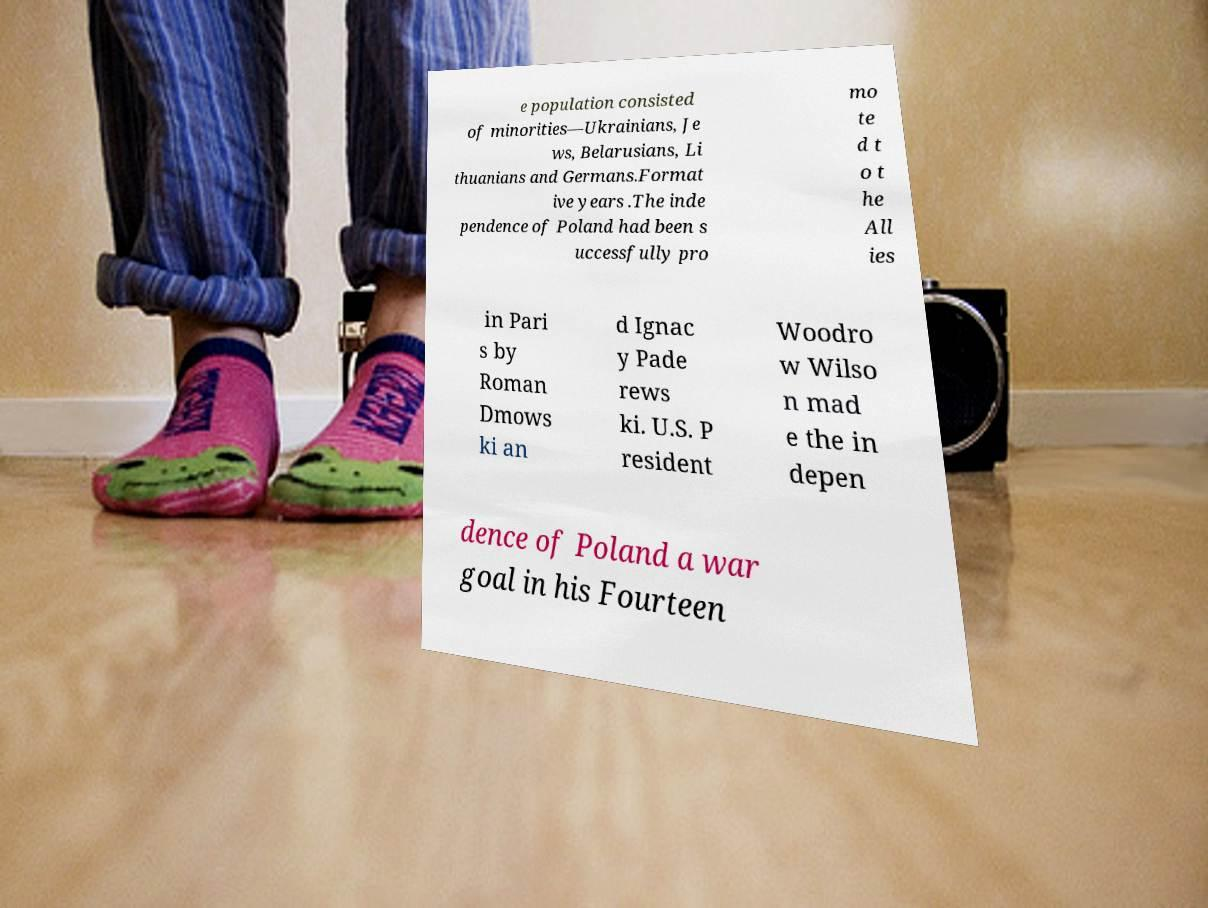Could you extract and type out the text from this image? e population consisted of minorities—Ukrainians, Je ws, Belarusians, Li thuanians and Germans.Format ive years .The inde pendence of Poland had been s uccessfully pro mo te d t o t he All ies in Pari s by Roman Dmows ki an d Ignac y Pade rews ki. U.S. P resident Woodro w Wilso n mad e the in depen dence of Poland a war goal in his Fourteen 